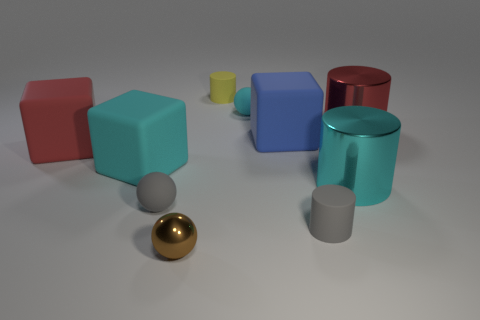Do the small rubber ball that is right of the brown metallic thing and the large shiny thing that is in front of the cyan block have the same color?
Give a very brief answer. Yes. The red cube has what size?
Offer a terse response. Large. There is a rubber cube that is to the right of the small gray ball; what size is it?
Offer a terse response. Large. The tiny rubber object that is both in front of the small yellow object and behind the large red shiny cylinder has what shape?
Ensure brevity in your answer.  Sphere. How many other things are the same shape as the small cyan object?
Provide a short and direct response. 2. What is the color of the metal thing that is the same size as the cyan rubber ball?
Keep it short and to the point. Brown. What number of objects are blue matte cubes or tiny yellow things?
Ensure brevity in your answer.  2. There is a large cyan metal cylinder; are there any large shiny cylinders behind it?
Your answer should be very brief. Yes. Is there another big object that has the same material as the large blue thing?
Offer a terse response. Yes. How many cylinders are tiny gray matte things or big rubber things?
Offer a terse response. 1. 